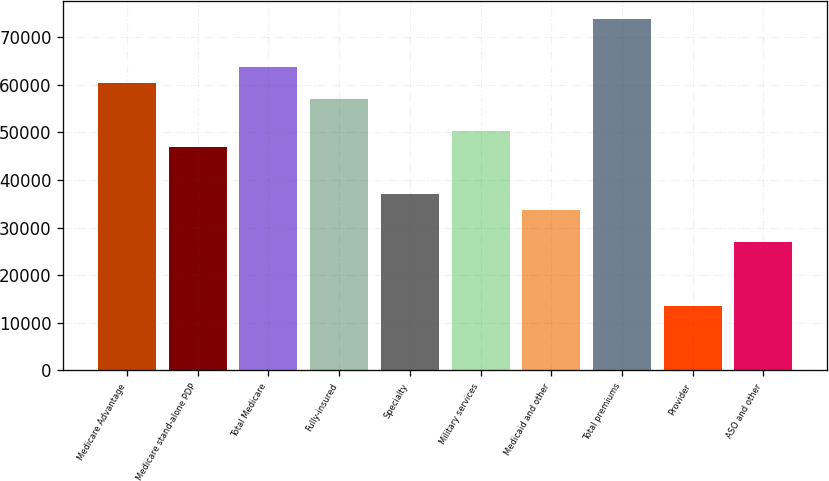Convert chart to OTSL. <chart><loc_0><loc_0><loc_500><loc_500><bar_chart><fcel>Medicare Advantage<fcel>Medicare stand-alone PDP<fcel>Total Medicare<fcel>Fully-insured<fcel>Specialty<fcel>Military services<fcel>Medicaid and other<fcel>Total premiums<fcel>Provider<fcel>ASO and other<nl><fcel>60472.1<fcel>47034.1<fcel>63831.7<fcel>57112.6<fcel>36955.5<fcel>50393.6<fcel>33596<fcel>73910.2<fcel>13438.9<fcel>26876.9<nl></chart> 